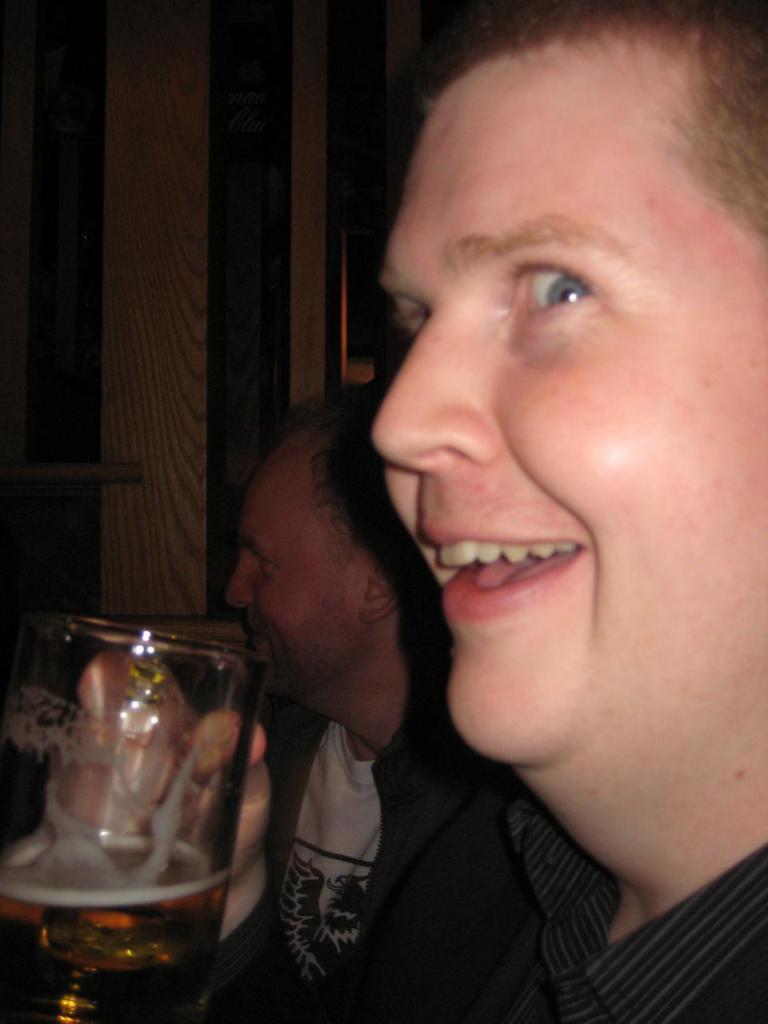Can you describe this image briefly? A man is smiling and holding a wine glass beside him there is another man sitting. 